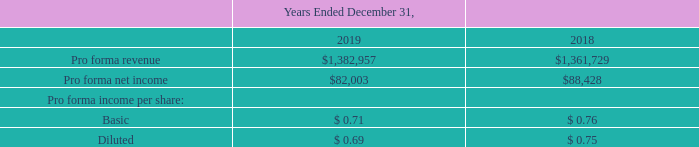Unaudited Pro Forma Financial Information
The pro forma financial information in the table below presents the combined results of operations for ACI and Speedpay as if the acquisition had occurred January 1, 2018. The pro forma information is shown for illustrative purposes only and is not necessarily indicative of future results of operations of the Company or results of operations of the Company that would have actually occurred had the transaction been in effect for the periods presented. This pro forma information is not intended to represent or be indicative of actual results had the acquisition occurred as of the beginning of each period, and does not reflect potential synergies, integration costs, or other such costs or savings.
Certain pro forma adjustments have been made to net income (loss) for the year ended December 31, 2019 and 2018, to give effect to estimated adjustments that remove the amortization expense on eliminated Speedpay historical identifiable intangible assets, add amortization expense for the value of acquired identified intangible assets (primarily acquired software, customer relationships, and trademarks), and add estimated interest expense on the Company’s additional Delayed Draw Term Loan and Revolving Credit Facility borrowings. Additionally, certain transaction expenses that are a direct result of the acquisition have been excluded from the year ended December 31, 2019.
The following is the unaudited summarized pro forma financial information for the periods presented (in thousands, except per share data):
Walletron
On May 9, 2019, the Company also completed the acquisition of Walletron, which delivers patented mobile wallet technology. The Company has included the financial results of Walletron in the consolidated financial statements from the date of acquisition, which were not material.
RevChip and TranSend
On October 1, 2019, the Company acquired certain technology assets of RevChip, LLC ("RevChip") and TranSend Integrated Technologies Inc. ("TranSend") for a combined $7.0 million. As substantially all of the value was in the developed technology, the purchase was recognized as an asset acquisition. The Company has included the financial results of RevChip and TranSend in the consolidated financial statements from the date of acquisition, which were not material.
What does Walletron deliver? Patented mobile wallet technology. How much did it cost the company to acquire certain technology assets of RevChip, LLC ("RevChip") and TranSend Integrated Technologies Inc. ("TranSend")?
Answer scale should be: million. $7.0 million. What was the pro forma revenue in 2019?
Answer scale should be: thousand. $1,382,957. What was the change in pro forma revenue between 2018 and 2019?
Answer scale should be: thousand. $1,382,957-$1,361,729
Answer: 21228. What was the change in pro forma net income between 2018 and 2019?
Answer scale should be: thousand. $82,003-$88,428
Answer: -6425. What was the percentage change in pro forma net income between 2018 and 2019?
Answer scale should be: percent. ($82,003-$88,428)/$88,428
Answer: -7.27. 